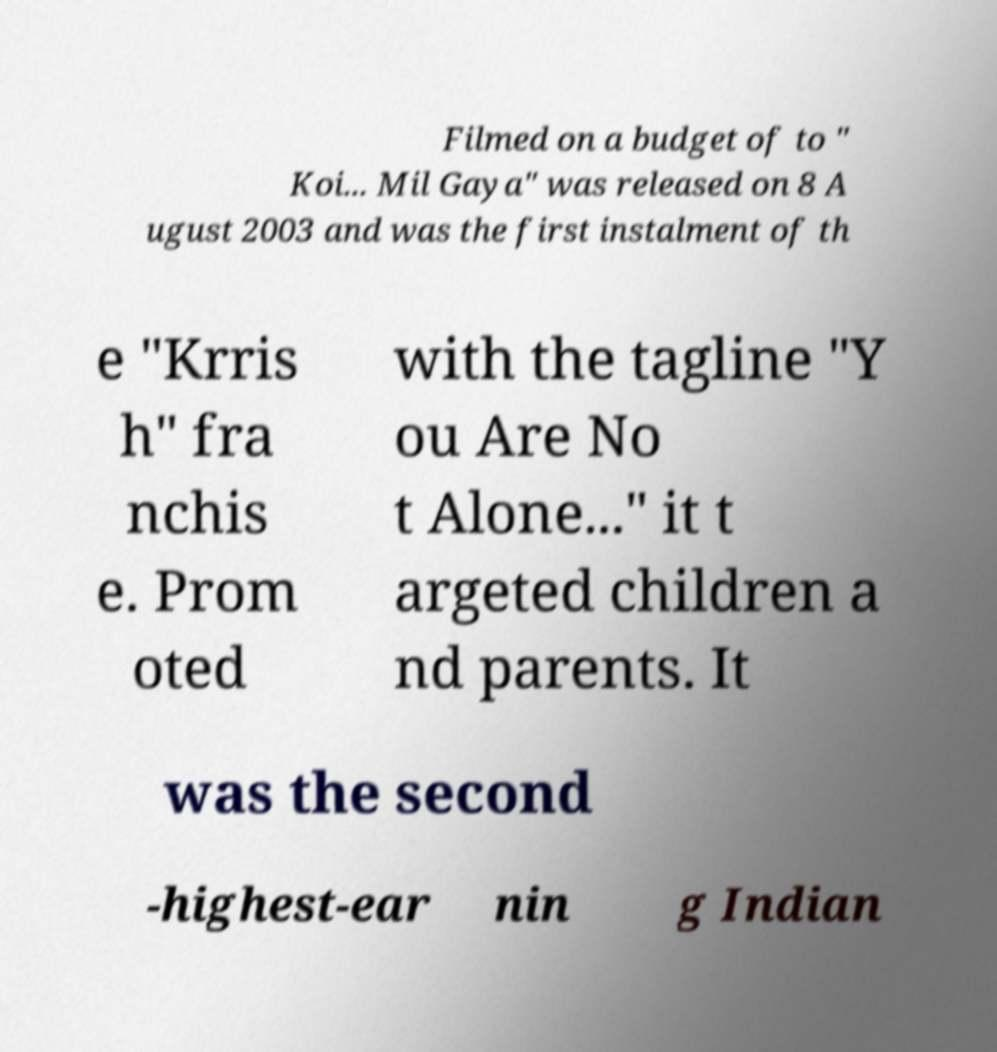What messages or text are displayed in this image? I need them in a readable, typed format. Filmed on a budget of to " Koi... Mil Gaya" was released on 8 A ugust 2003 and was the first instalment of th e "Krris h" fra nchis e. Prom oted with the tagline "Y ou Are No t Alone..." it t argeted children a nd parents. It was the second -highest-ear nin g Indian 